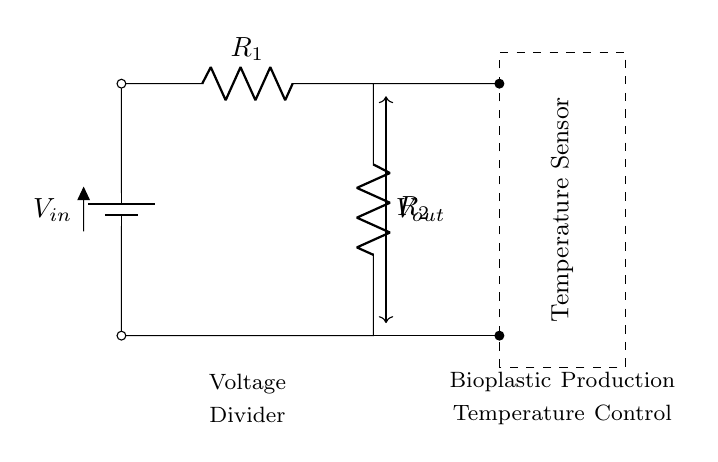What is the type of this circuit? This circuit is a voltage divider, which is made up of two resistors connected in series across a voltage source. The arrangement of resistors and the battery indicates that it's designed to provide a specific output voltage dependent on the resistor values.
Answer: voltage divider What are the values of the resistors? The resistors in the circuit are labeled as R1 and R2. However, the actual numerical values are not specified in the diagram. The circuit focuses on their roles rather than specific values.
Answer: R1 and R2 What does the output voltage represent? The output voltage, denoted by Vout, is the voltage measured across the second resistor (R2) in the voltage divider configuration. It is critical for controlling the temperature in bioplastic production.
Answer: Vout Which component senses temperature? The component labeled as "Temperature Sensor" in the circuit is responsible for sensing temperature. It is connected to the output of the voltage divider, which indicates that it will utilize the voltage to monitor temperature changes.
Answer: Temperature Sensor Why is a voltage divider used in this circuit? A voltage divider is utilized in this circuit for precise control of the output voltage (Vout), which is necessary for the accurate temperature control required in bioplastic production processes. By carefully selecting the resistor values, the output voltage can be tailored to match the desired setpoint for temperature control.
Answer: Precise control of output voltage How is the system powered? The circuit is powered by the battery labeled as Vin, which serves as the input voltage for the voltage divider. This battery is essential for providing the electrical energy needed to operate the entire circuit including the temperature sensor.
Answer: Battery labeled Vin What is the function of the dashed rectangle? The dashed rectangle around the Temperature Sensor signifies the component's importance and encapsulates it visually, indicating it is a crucial part of the system for temperature control in the circuit. It is a common practice in circuit diagrams to highlight significant components this way.
Answer: Signifies importance of the sensor 